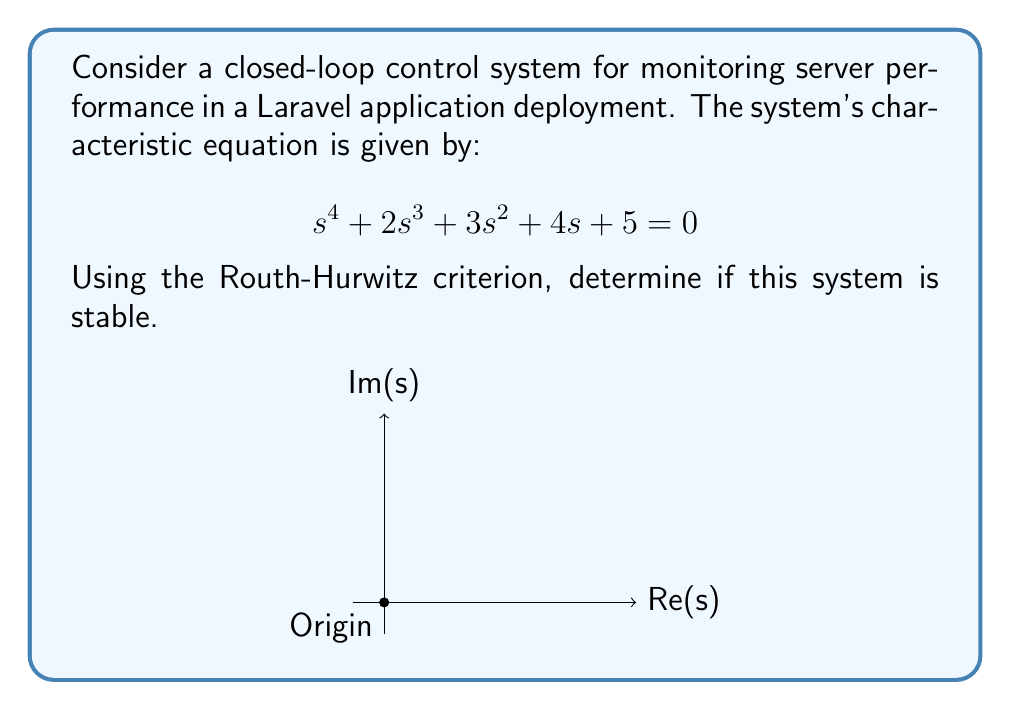What is the answer to this math problem? To analyze the stability using the Routh-Hurwitz criterion, we follow these steps:

1) Construct the Routh array:

   $$\begin{array}{c|cccc}
   s^4 & 1 & 3 & 5 \\
   s^3 & 2 & 4 & 0 \\
   s^2 & a & b & 0 \\
   s^1 & c & 0 & 0 \\
   s^0 & d & 0 & 0
   \end{array}$$

2) Calculate the values for $a$, $b$, $c$, and $d$:

   $a = \frac{(2)(3) - (1)(4)}{2} = 1$
   
   $b = \frac{(2)(5) - (1)(0)}{2} = 5$
   
   $c = \frac{(1)(5) - (1)(0)}{1} = 5$
   
   $d = 5$

3) The complete Routh array:

   $$\begin{array}{c|cccc}
   s^4 & 1 & 3 & 5 \\
   s^3 & 2 & 4 & 0 \\
   s^2 & 1 & 5 & 0 \\
   s^1 & 5 & 0 & 0 \\
   s^0 & 5 & 0 & 0
   \end{array}$$

4) Analyze the first column of the Routh array:
   All elements in the first column (1, 2, 1, 5, 5) are positive and non-zero.

5) According to the Routh-Hurwitz criterion, if all elements in the first column of the Routh array are positive, the system is stable.

Therefore, since all elements in the first column are positive, the closed-loop control system for monitoring server performance in the Laravel application deployment is stable.
Answer: Stable 